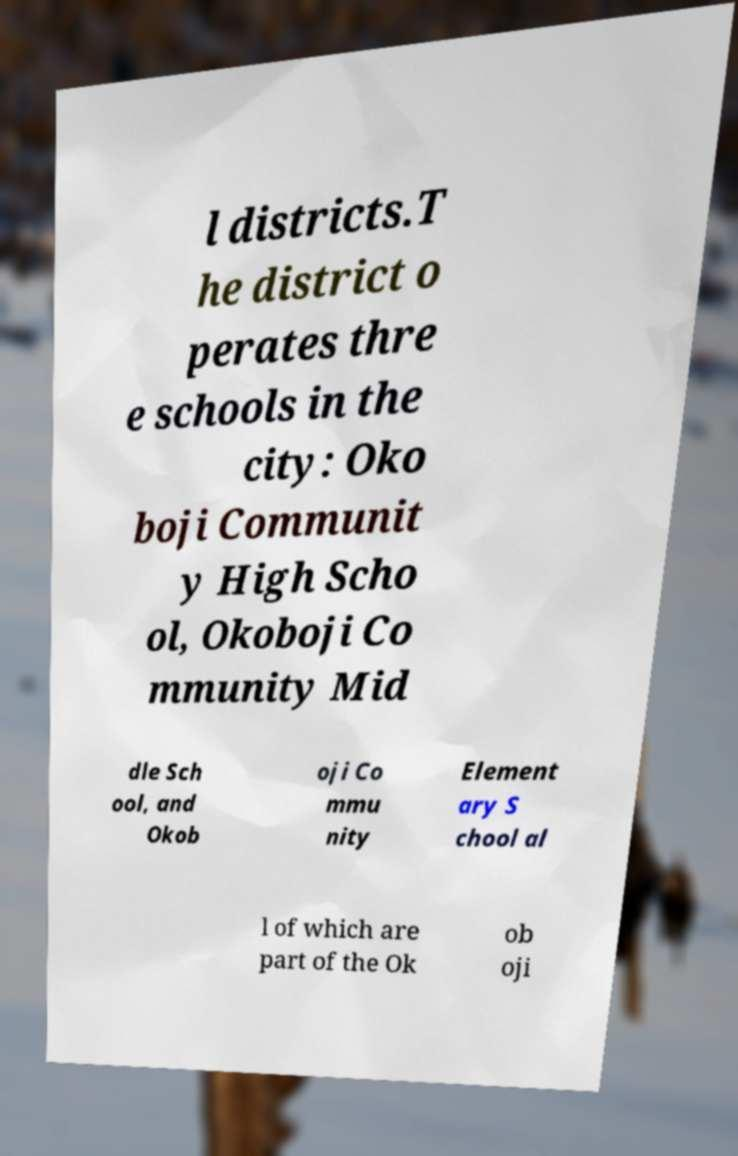I need the written content from this picture converted into text. Can you do that? l districts.T he district o perates thre e schools in the city: Oko boji Communit y High Scho ol, Okoboji Co mmunity Mid dle Sch ool, and Okob oji Co mmu nity Element ary S chool al l of which are part of the Ok ob oji 